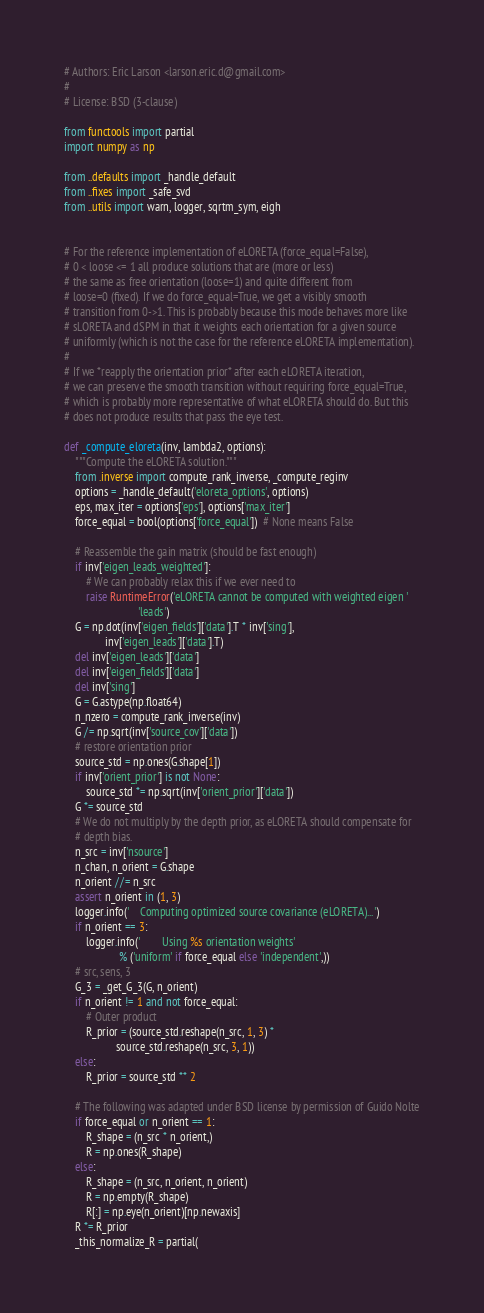Convert code to text. <code><loc_0><loc_0><loc_500><loc_500><_Python_># Authors: Eric Larson <larson.eric.d@gmail.com>
#
# License: BSD (3-clause)

from functools import partial
import numpy as np

from ..defaults import _handle_default
from ..fixes import _safe_svd
from ..utils import warn, logger, sqrtm_sym, eigh


# For the reference implementation of eLORETA (force_equal=False),
# 0 < loose <= 1 all produce solutions that are (more or less)
# the same as free orientation (loose=1) and quite different from
# loose=0 (fixed). If we do force_equal=True, we get a visibly smooth
# transition from 0->1. This is probably because this mode behaves more like
# sLORETA and dSPM in that it weights each orientation for a given source
# uniformly (which is not the case for the reference eLORETA implementation).
#
# If we *reapply the orientation prior* after each eLORETA iteration,
# we can preserve the smooth transition without requiring force_equal=True,
# which is probably more representative of what eLORETA should do. But this
# does not produce results that pass the eye test.

def _compute_eloreta(inv, lambda2, options):
    """Compute the eLORETA solution."""
    from .inverse import compute_rank_inverse, _compute_reginv
    options = _handle_default('eloreta_options', options)
    eps, max_iter = options['eps'], options['max_iter']
    force_equal = bool(options['force_equal'])  # None means False

    # Reassemble the gain matrix (should be fast enough)
    if inv['eigen_leads_weighted']:
        # We can probably relax this if we ever need to
        raise RuntimeError('eLORETA cannot be computed with weighted eigen '
                           'leads')
    G = np.dot(inv['eigen_fields']['data'].T * inv['sing'],
               inv['eigen_leads']['data'].T)
    del inv['eigen_leads']['data']
    del inv['eigen_fields']['data']
    del inv['sing']
    G = G.astype(np.float64)
    n_nzero = compute_rank_inverse(inv)
    G /= np.sqrt(inv['source_cov']['data'])
    # restore orientation prior
    source_std = np.ones(G.shape[1])
    if inv['orient_prior'] is not None:
        source_std *= np.sqrt(inv['orient_prior']['data'])
    G *= source_std
    # We do not multiply by the depth prior, as eLORETA should compensate for
    # depth bias.
    n_src = inv['nsource']
    n_chan, n_orient = G.shape
    n_orient //= n_src
    assert n_orient in (1, 3)
    logger.info('    Computing optimized source covariance (eLORETA)...')
    if n_orient == 3:
        logger.info('        Using %s orientation weights'
                    % ('uniform' if force_equal else 'independent',))
    # src, sens, 3
    G_3 = _get_G_3(G, n_orient)
    if n_orient != 1 and not force_equal:
        # Outer product
        R_prior = (source_std.reshape(n_src, 1, 3) *
                   source_std.reshape(n_src, 3, 1))
    else:
        R_prior = source_std ** 2

    # The following was adapted under BSD license by permission of Guido Nolte
    if force_equal or n_orient == 1:
        R_shape = (n_src * n_orient,)
        R = np.ones(R_shape)
    else:
        R_shape = (n_src, n_orient, n_orient)
        R = np.empty(R_shape)
        R[:] = np.eye(n_orient)[np.newaxis]
    R *= R_prior
    _this_normalize_R = partial(</code> 